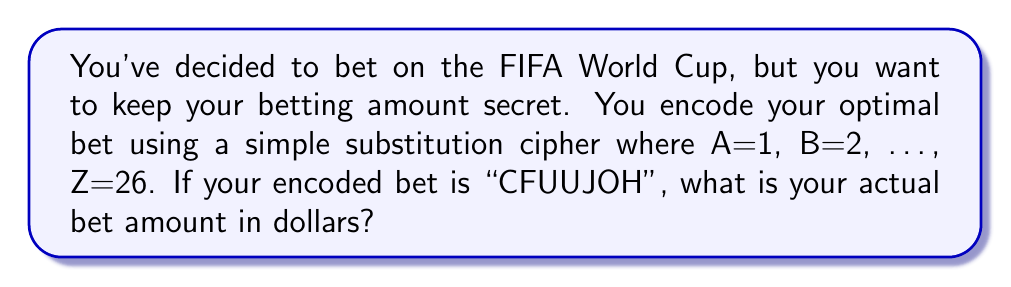Show me your answer to this math problem. Let's approach this step-by-step:

1) First, we need to decode the message "CFUUJOH" using the given cipher.

2) The cipher is: A=1, B=2, C=3, D=4, ..., Z=26

3) Let's decode each letter:
   C = 3
   F = 6
   U = 21
   T = 20
   I = 9
   N = 14
   G = 7

4) Now, we need to shift each number back by 1 to get the original letter:
   3 - 1 = 2  (B)
   6 - 1 = 5  (E)
   21 - 1 = 20 (T)
   20 - 1 = 19 (S)
   9 - 1 = 8   (H)
   14 - 1 = 13 (M)
   7 - 1 = 6   (F)

5) This gives us the decoded word: BETTING

6) To get the numerical value, we need to convert this word to numbers again using A=1, B=2, ..., Z=26:

   B = 2
   E = 5
   T = 20
   T = 20
   I = 9
   N = 14
   G = 7

7) Now, we sum these numbers:

   $$2 + 5 + 20 + 20 + 9 + 14 + 7 = 77$$

Therefore, the optimal bet amount is $77.
Answer: $77 